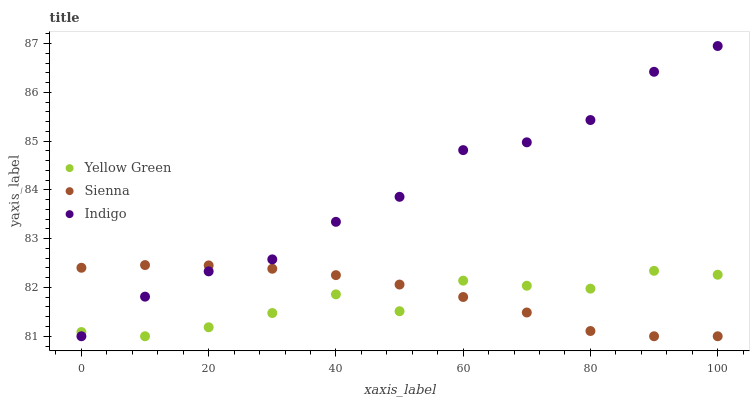Does Yellow Green have the minimum area under the curve?
Answer yes or no. Yes. Does Indigo have the maximum area under the curve?
Answer yes or no. Yes. Does Indigo have the minimum area under the curve?
Answer yes or no. No. Does Yellow Green have the maximum area under the curve?
Answer yes or no. No. Is Sienna the smoothest?
Answer yes or no. Yes. Is Indigo the roughest?
Answer yes or no. Yes. Is Yellow Green the smoothest?
Answer yes or no. No. Is Yellow Green the roughest?
Answer yes or no. No. Does Sienna have the lowest value?
Answer yes or no. Yes. Does Indigo have the highest value?
Answer yes or no. Yes. Does Yellow Green have the highest value?
Answer yes or no. No. Does Yellow Green intersect Sienna?
Answer yes or no. Yes. Is Yellow Green less than Sienna?
Answer yes or no. No. Is Yellow Green greater than Sienna?
Answer yes or no. No. 